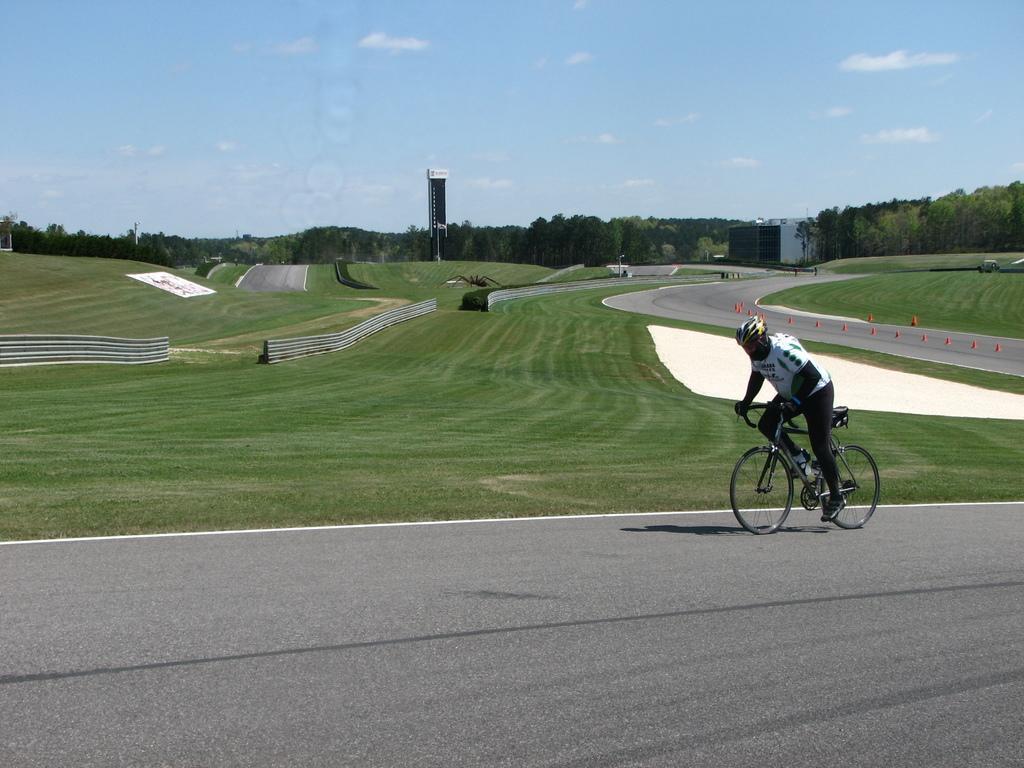In one or two sentences, can you explain what this image depicts? In this picture in the center there is a person riding a bicycle on the road. In the background there is grass on the ground, there is a fence, there are trees and the sky is cloudy and there is a tower. 